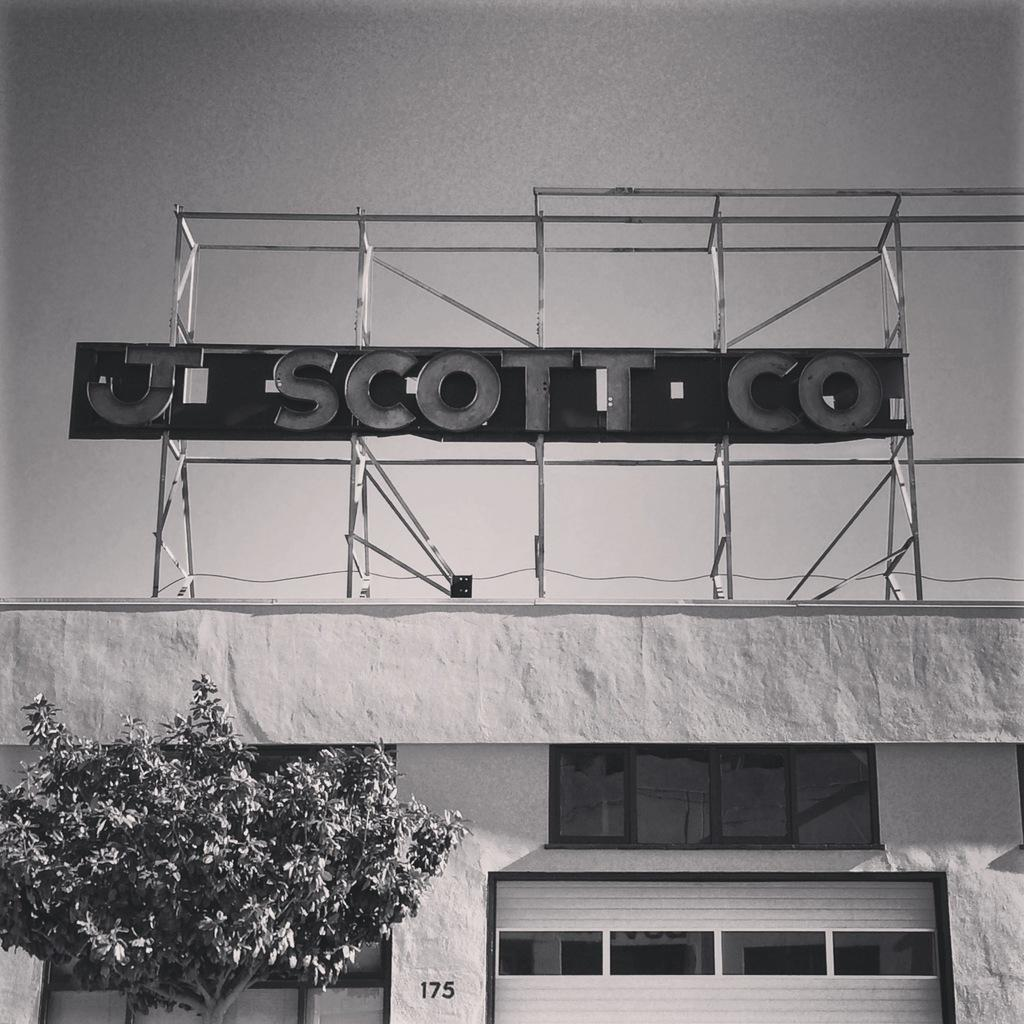<image>
Describe the image concisely. A sign that says "J Scott Co" is located above a stucco building with a garage door. 